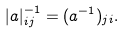<formula> <loc_0><loc_0><loc_500><loc_500>| a | _ { i j } ^ { - 1 } = ( a ^ { - 1 } ) _ { j i } .</formula> 